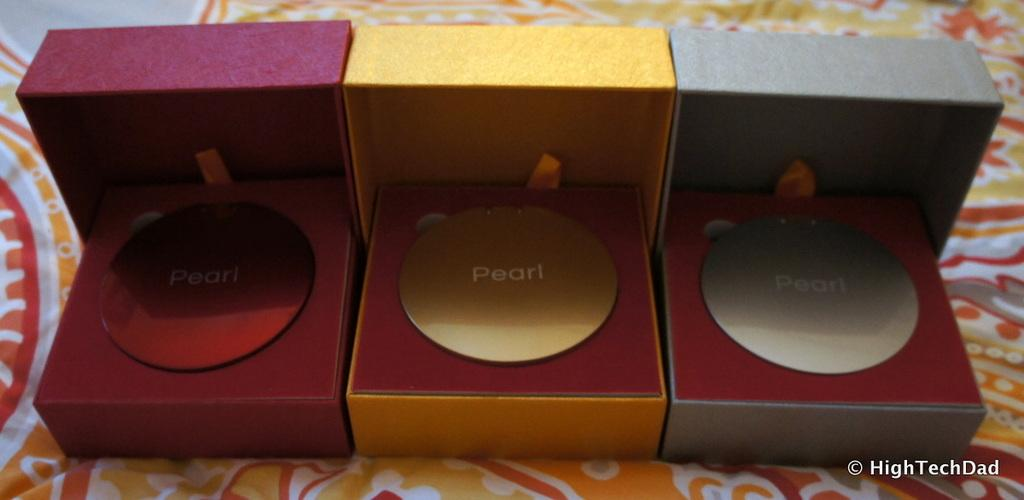How many boxes are present in the image? There are three different colored boxes in the image. What is written inside each box? The word "pearl" is written inside each box. How many family members are present in the image? There are no family members present in the image; it only features three different colored boxes with the word "pearl" written inside each one. 